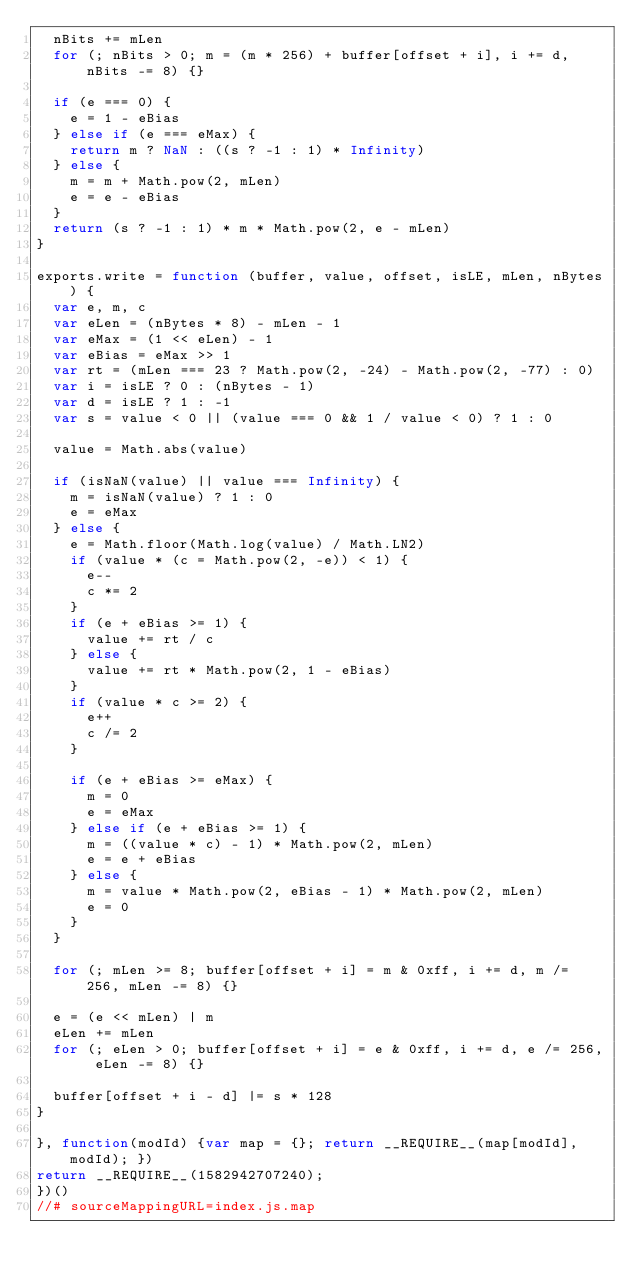<code> <loc_0><loc_0><loc_500><loc_500><_JavaScript_>  nBits += mLen
  for (; nBits > 0; m = (m * 256) + buffer[offset + i], i += d, nBits -= 8) {}

  if (e === 0) {
    e = 1 - eBias
  } else if (e === eMax) {
    return m ? NaN : ((s ? -1 : 1) * Infinity)
  } else {
    m = m + Math.pow(2, mLen)
    e = e - eBias
  }
  return (s ? -1 : 1) * m * Math.pow(2, e - mLen)
}

exports.write = function (buffer, value, offset, isLE, mLen, nBytes) {
  var e, m, c
  var eLen = (nBytes * 8) - mLen - 1
  var eMax = (1 << eLen) - 1
  var eBias = eMax >> 1
  var rt = (mLen === 23 ? Math.pow(2, -24) - Math.pow(2, -77) : 0)
  var i = isLE ? 0 : (nBytes - 1)
  var d = isLE ? 1 : -1
  var s = value < 0 || (value === 0 && 1 / value < 0) ? 1 : 0

  value = Math.abs(value)

  if (isNaN(value) || value === Infinity) {
    m = isNaN(value) ? 1 : 0
    e = eMax
  } else {
    e = Math.floor(Math.log(value) / Math.LN2)
    if (value * (c = Math.pow(2, -e)) < 1) {
      e--
      c *= 2
    }
    if (e + eBias >= 1) {
      value += rt / c
    } else {
      value += rt * Math.pow(2, 1 - eBias)
    }
    if (value * c >= 2) {
      e++
      c /= 2
    }

    if (e + eBias >= eMax) {
      m = 0
      e = eMax
    } else if (e + eBias >= 1) {
      m = ((value * c) - 1) * Math.pow(2, mLen)
      e = e + eBias
    } else {
      m = value * Math.pow(2, eBias - 1) * Math.pow(2, mLen)
      e = 0
    }
  }

  for (; mLen >= 8; buffer[offset + i] = m & 0xff, i += d, m /= 256, mLen -= 8) {}

  e = (e << mLen) | m
  eLen += mLen
  for (; eLen > 0; buffer[offset + i] = e & 0xff, i += d, e /= 256, eLen -= 8) {}

  buffer[offset + i - d] |= s * 128
}

}, function(modId) {var map = {}; return __REQUIRE__(map[modId], modId); })
return __REQUIRE__(1582942707240);
})()
//# sourceMappingURL=index.js.map</code> 